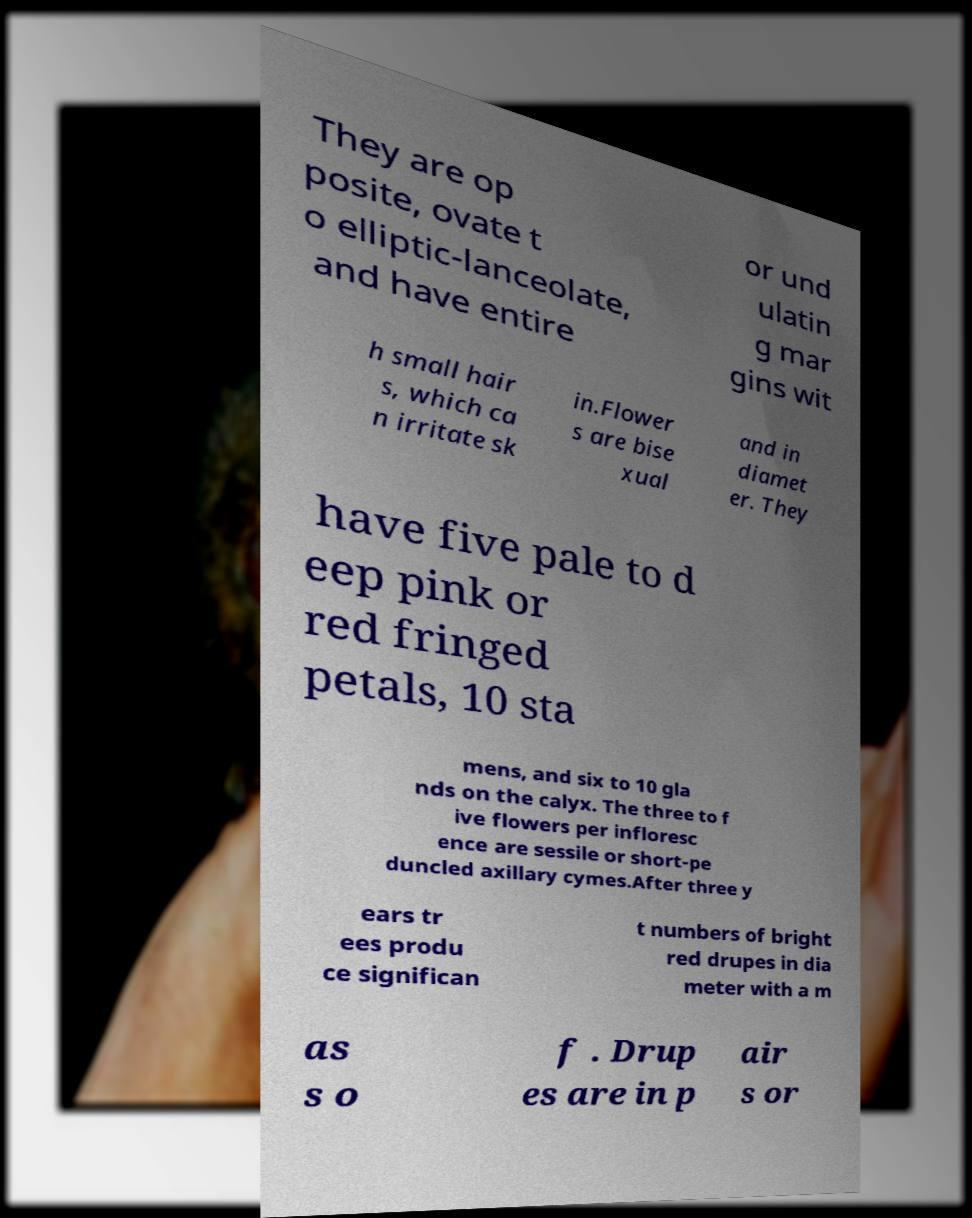What messages or text are displayed in this image? I need them in a readable, typed format. They are op posite, ovate t o elliptic-lanceolate, and have entire or und ulatin g mar gins wit h small hair s, which ca n irritate sk in.Flower s are bise xual and in diamet er. They have five pale to d eep pink or red fringed petals, 10 sta mens, and six to 10 gla nds on the calyx. The three to f ive flowers per infloresc ence are sessile or short-pe duncled axillary cymes.After three y ears tr ees produ ce significan t numbers of bright red drupes in dia meter with a m as s o f . Drup es are in p air s or 